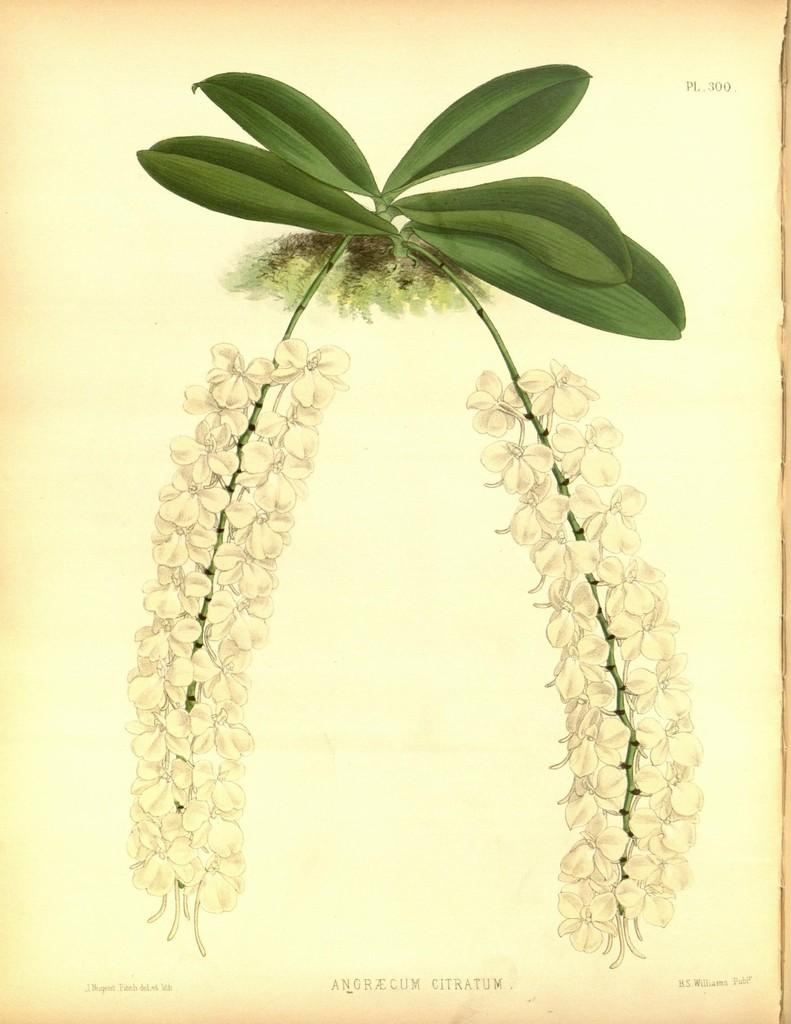What is the primary color of the poster in the image? The poster in the image is white. What is depicted on the white poster? The poster has green leaves drawn on it. How many fingers can be seen on the poster in the image? There are no fingers depicted on the poster in the image; it features a drawing of green leaves. 